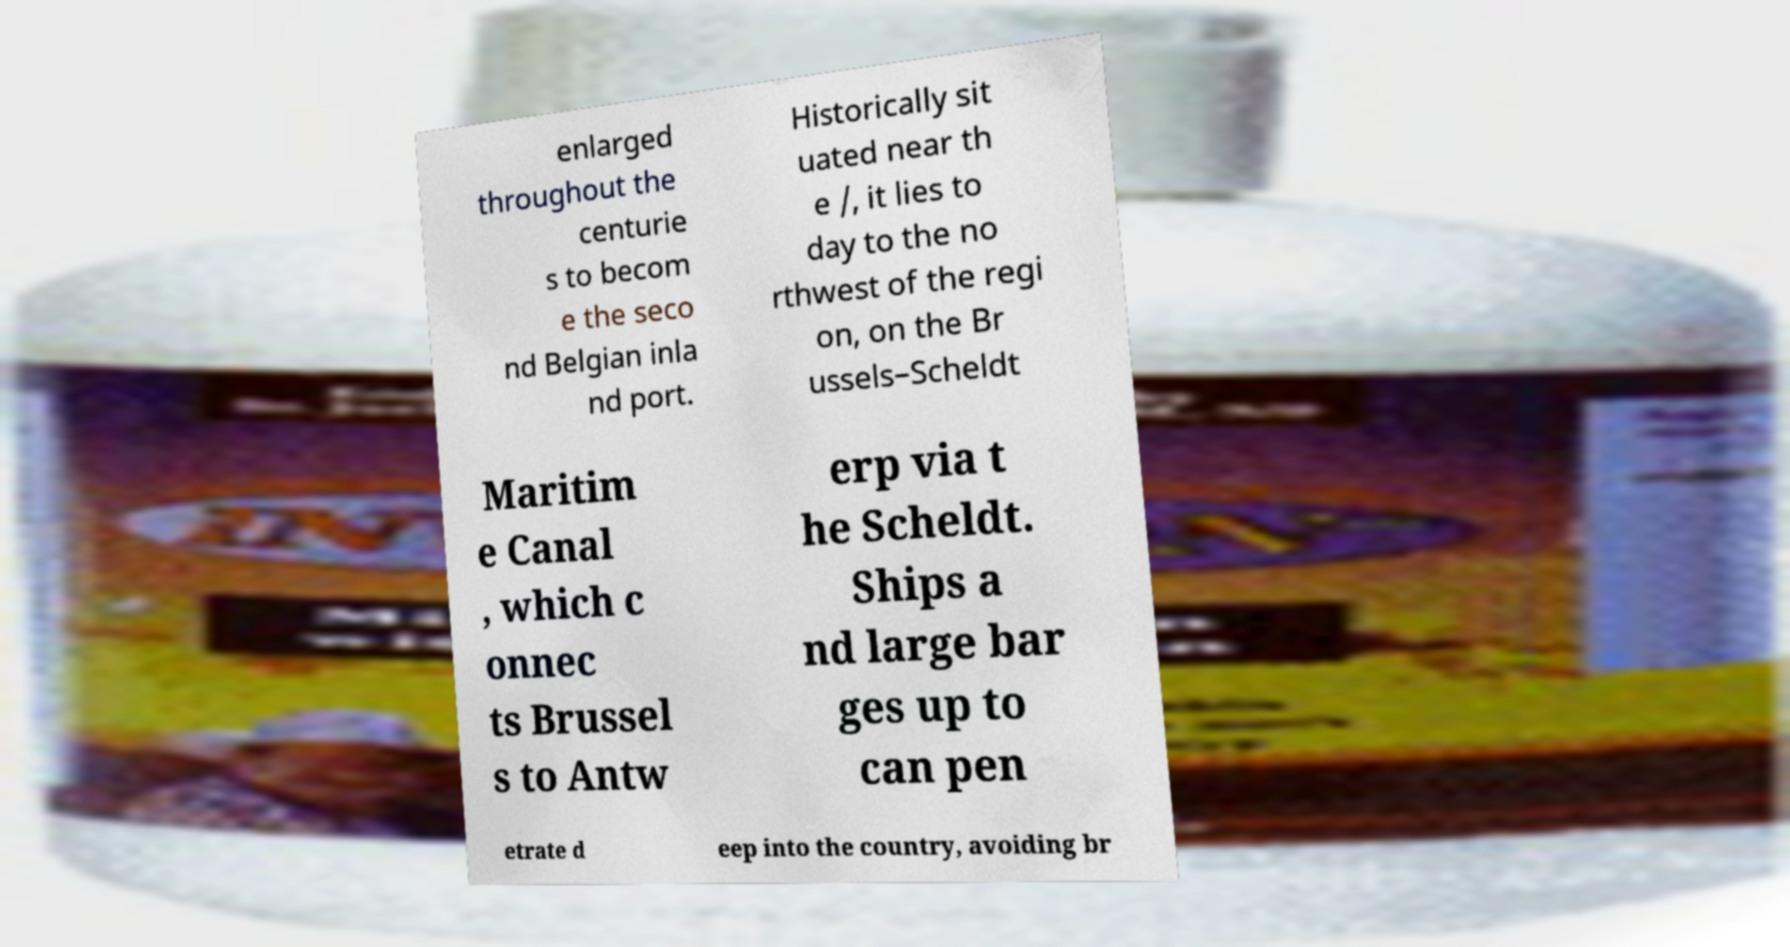Can you accurately transcribe the text from the provided image for me? enlarged throughout the centurie s to becom e the seco nd Belgian inla nd port. Historically sit uated near th e /, it lies to day to the no rthwest of the regi on, on the Br ussels–Scheldt Maritim e Canal , which c onnec ts Brussel s to Antw erp via t he Scheldt. Ships a nd large bar ges up to can pen etrate d eep into the country, avoiding br 